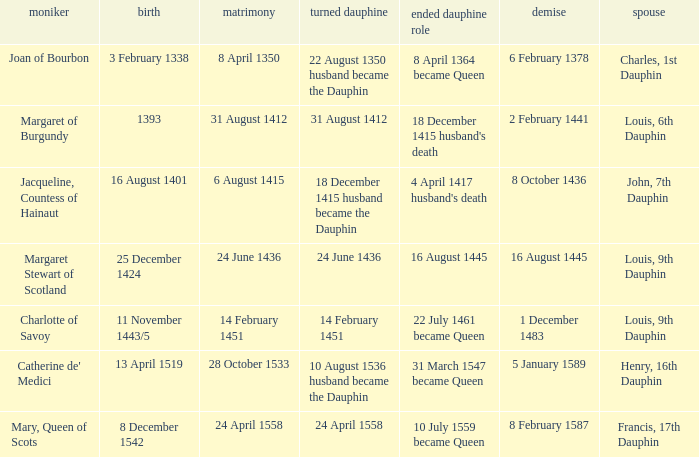When was the death when the birth was 8 december 1542? 8 February 1587. 